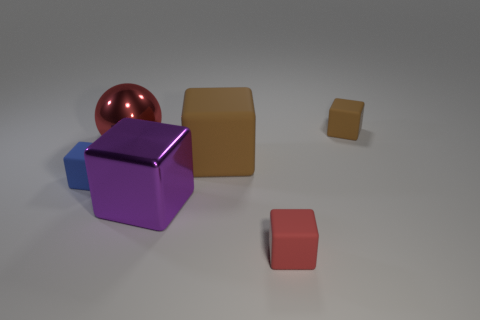Subtract 2 blocks. How many blocks are left? 3 Subtract all blue cubes. How many cubes are left? 4 Subtract all tiny blue cubes. How many cubes are left? 4 Subtract all gray cubes. Subtract all blue spheres. How many cubes are left? 5 Add 2 tiny red matte blocks. How many objects exist? 8 Subtract all blocks. How many objects are left? 1 Subtract all big metal blocks. Subtract all matte cubes. How many objects are left? 1 Add 4 small red rubber cubes. How many small red rubber cubes are left? 5 Add 2 large purple cubes. How many large purple cubes exist? 3 Subtract 0 cyan balls. How many objects are left? 6 